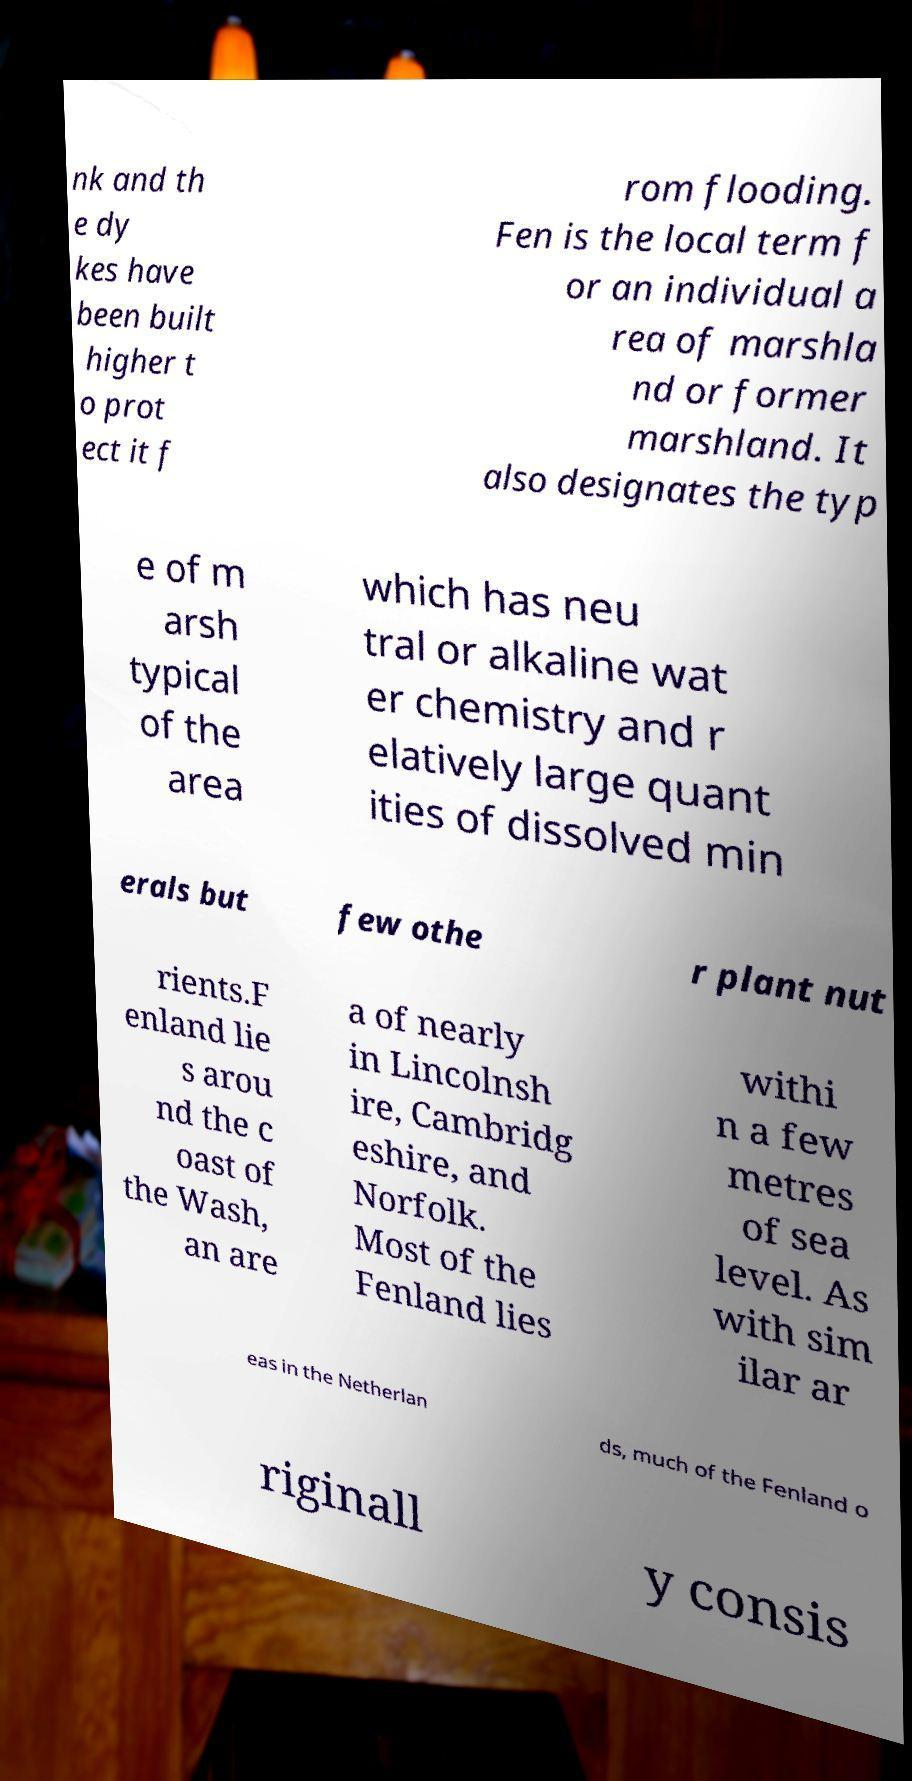There's text embedded in this image that I need extracted. Can you transcribe it verbatim? nk and th e dy kes have been built higher t o prot ect it f rom flooding. Fen is the local term f or an individual a rea of marshla nd or former marshland. It also designates the typ e of m arsh typical of the area which has neu tral or alkaline wat er chemistry and r elatively large quant ities of dissolved min erals but few othe r plant nut rients.F enland lie s arou nd the c oast of the Wash, an are a of nearly in Lincolnsh ire, Cambridg eshire, and Norfolk. Most of the Fenland lies withi n a few metres of sea level. As with sim ilar ar eas in the Netherlan ds, much of the Fenland o riginall y consis 